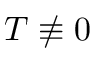<formula> <loc_0><loc_0><loc_500><loc_500>T \not \equiv 0</formula> 